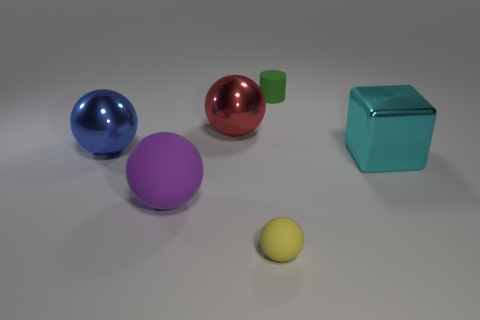There is a metal thing that is to the right of the tiny thing in front of the blue thing that is to the left of the small green object; what is its size?
Offer a terse response. Large. There is a tiny thing that is in front of the small thing behind the big metal block; is there a green object that is on the right side of it?
Your answer should be compact. Yes. Is the shape of the small yellow thing the same as the tiny green matte thing?
Ensure brevity in your answer.  No. Is the number of blocks in front of the cyan cube less than the number of green cylinders?
Offer a very short reply. Yes. The small rubber thing behind the blue object that is in front of the tiny thing that is behind the big cyan metallic thing is what color?
Your answer should be very brief. Green. How many metal objects are either large purple things or red things?
Keep it short and to the point. 1. Does the blue ball have the same size as the green matte cylinder?
Offer a terse response. No. Are there fewer large balls that are in front of the red sphere than big objects that are behind the large purple sphere?
Your answer should be compact. Yes. How big is the green matte cylinder?
Your response must be concise. Small. What number of large objects are cyan balls or purple spheres?
Offer a terse response. 1. 